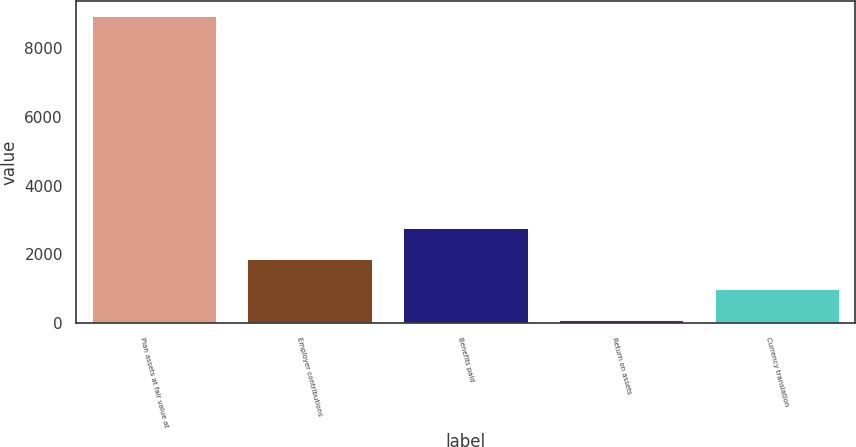Convert chart. <chart><loc_0><loc_0><loc_500><loc_500><bar_chart><fcel>Plan assets at fair value at<fcel>Employer contributions<fcel>Benefits paid<fcel>Return on assets<fcel>Currency translation<nl><fcel>8936<fcel>1870.2<fcel>2759.8<fcel>91<fcel>980.6<nl></chart> 